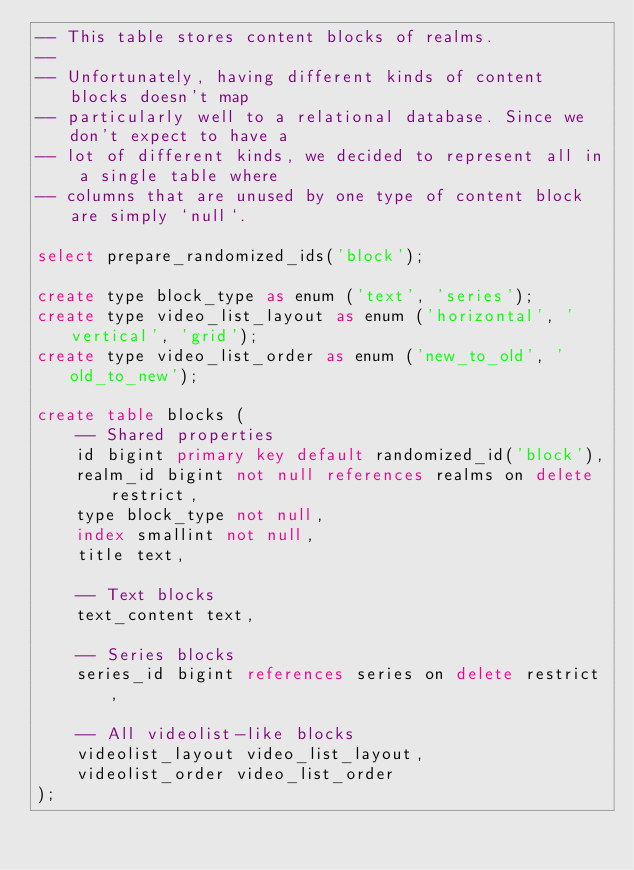<code> <loc_0><loc_0><loc_500><loc_500><_SQL_>-- This table stores content blocks of realms.
--
-- Unfortunately, having different kinds of content blocks doesn't map
-- particularly well to a relational database. Since we don't expect to have a
-- lot of different kinds, we decided to represent all in a single table where
-- columns that are unused by one type of content block are simply `null`.

select prepare_randomized_ids('block');

create type block_type as enum ('text', 'series');
create type video_list_layout as enum ('horizontal', 'vertical', 'grid');
create type video_list_order as enum ('new_to_old', 'old_to_new');

create table blocks (
    -- Shared properties
    id bigint primary key default randomized_id('block'),
    realm_id bigint not null references realms on delete restrict,
    type block_type not null,
    index smallint not null,
    title text,

    -- Text blocks
    text_content text,

    -- Series blocks
    series_id bigint references series on delete restrict,

    -- All videolist-like blocks
    videolist_layout video_list_layout,
    videolist_order video_list_order
);
</code> 